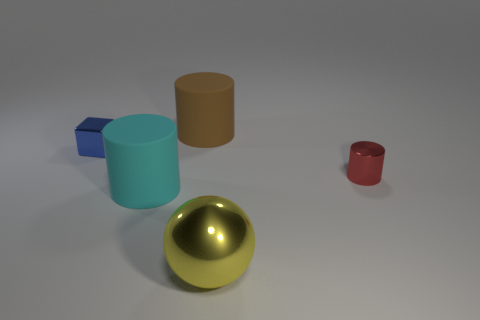Is there a tiny red object of the same shape as the brown thing?
Make the answer very short. Yes. There is a rubber cylinder that is in front of the matte cylinder that is behind the small blue cube; what is its size?
Ensure brevity in your answer.  Large. What number of shiny objects are large cyan objects or large brown things?
Your answer should be compact. 0. What number of blue cubes are there?
Offer a very short reply. 1. Are the tiny object that is on the left side of the tiny metal cylinder and the tiny thing in front of the tiny blue cube made of the same material?
Your answer should be compact. Yes. What is the color of the small object that is the same shape as the large brown object?
Your answer should be compact. Red. What material is the small object right of the cyan object that is left of the big brown cylinder made of?
Offer a terse response. Metal. There is a large matte object right of the large cyan rubber thing; is its shape the same as the small thing to the left of the yellow shiny thing?
Your answer should be very brief. No. There is a object that is both to the left of the big brown rubber cylinder and behind the small cylinder; what size is it?
Give a very brief answer. Small. What number of other objects are the same color as the large shiny ball?
Offer a very short reply. 0. 